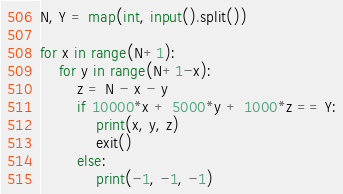Convert code to text. <code><loc_0><loc_0><loc_500><loc_500><_Python_>N, Y = map(int, input().split())

for x in range(N+1):
    for y in range(N+1-x):
        z = N - x - y
        if 10000*x + 5000*y + 1000*z == Y:
            print(x, y, z)
            exit()
        else:
            print(-1, -1, -1)</code> 